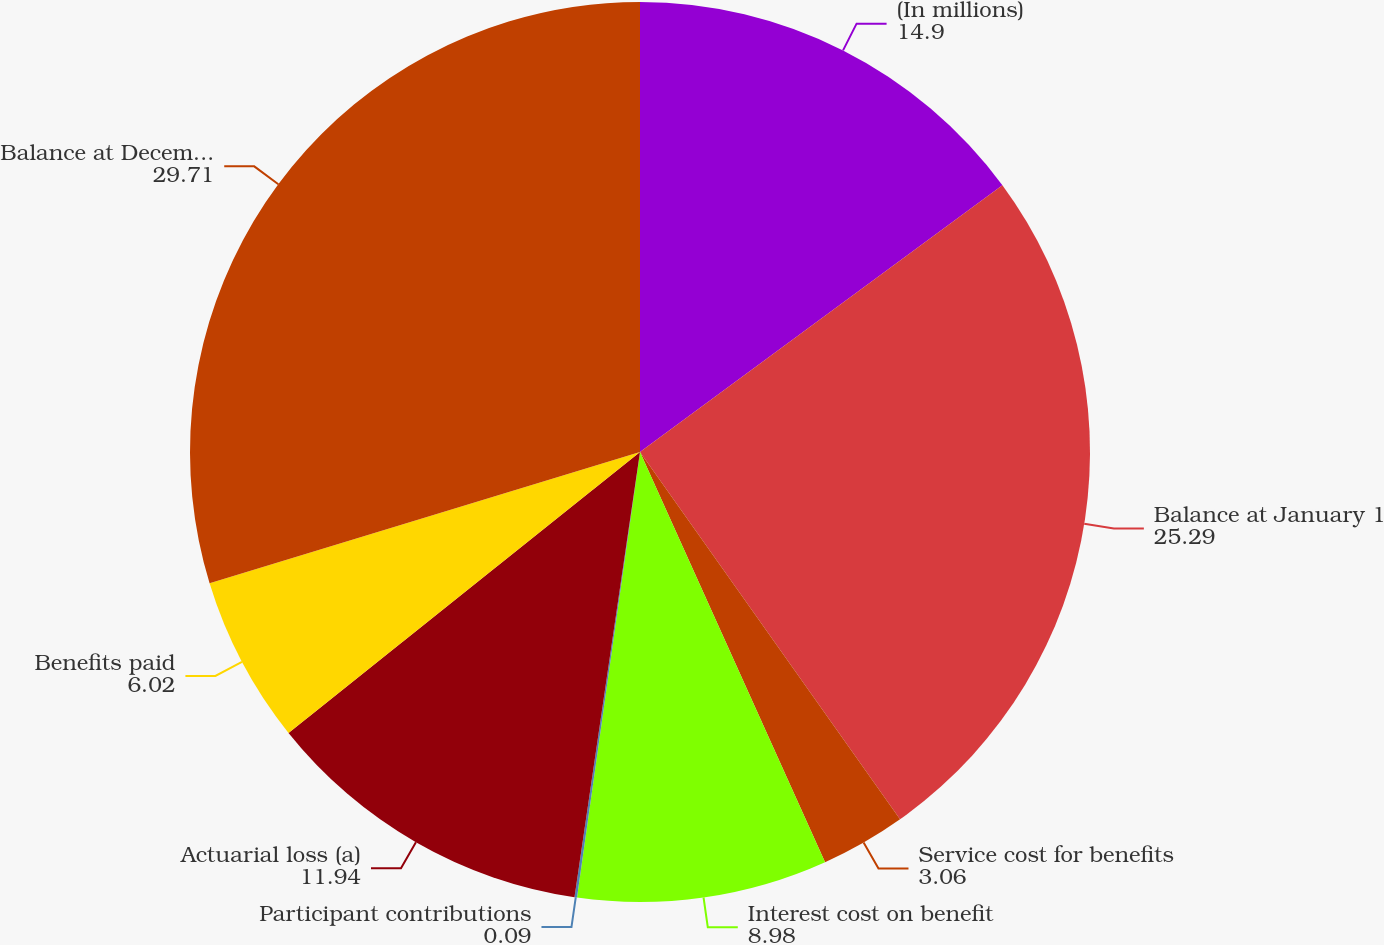<chart> <loc_0><loc_0><loc_500><loc_500><pie_chart><fcel>(In millions)<fcel>Balance at January 1<fcel>Service cost for benefits<fcel>Interest cost on benefit<fcel>Participant contributions<fcel>Actuarial loss (a)<fcel>Benefits paid<fcel>Balance at December 31 (b)<nl><fcel>14.9%<fcel>25.29%<fcel>3.06%<fcel>8.98%<fcel>0.09%<fcel>11.94%<fcel>6.02%<fcel>29.71%<nl></chart> 